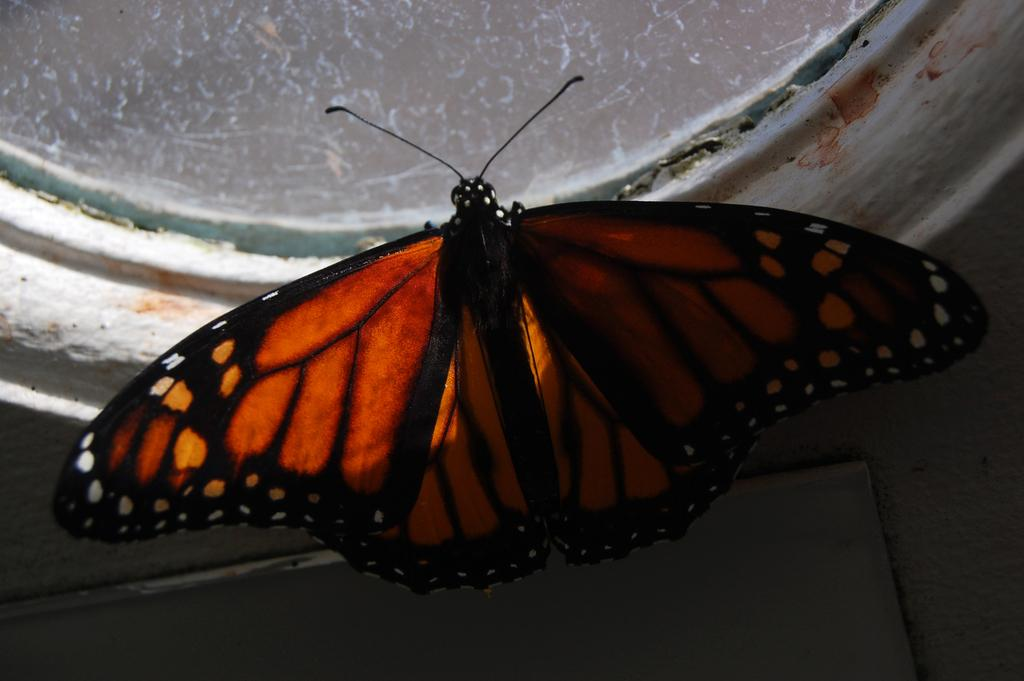What is the main feature in the center of the image? There is a wall in the center of the image. What is on the wall? There is a glass window and a butterfly on the wall. Can you describe the butterfly? The butterfly has brown, black, and white colors. What type of adjustment is the butterfly making to its trousers in the image? There are no trousers present in the image, as the butterfly is an insect and does not wear clothing. 